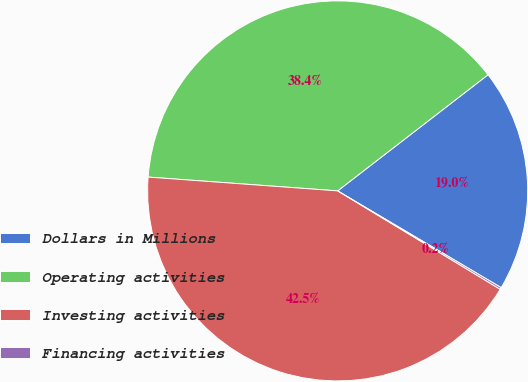<chart> <loc_0><loc_0><loc_500><loc_500><pie_chart><fcel>Dollars in Millions<fcel>Operating activities<fcel>Investing activities<fcel>Financing activities<nl><fcel>18.97%<fcel>38.38%<fcel>42.5%<fcel>0.16%<nl></chart> 